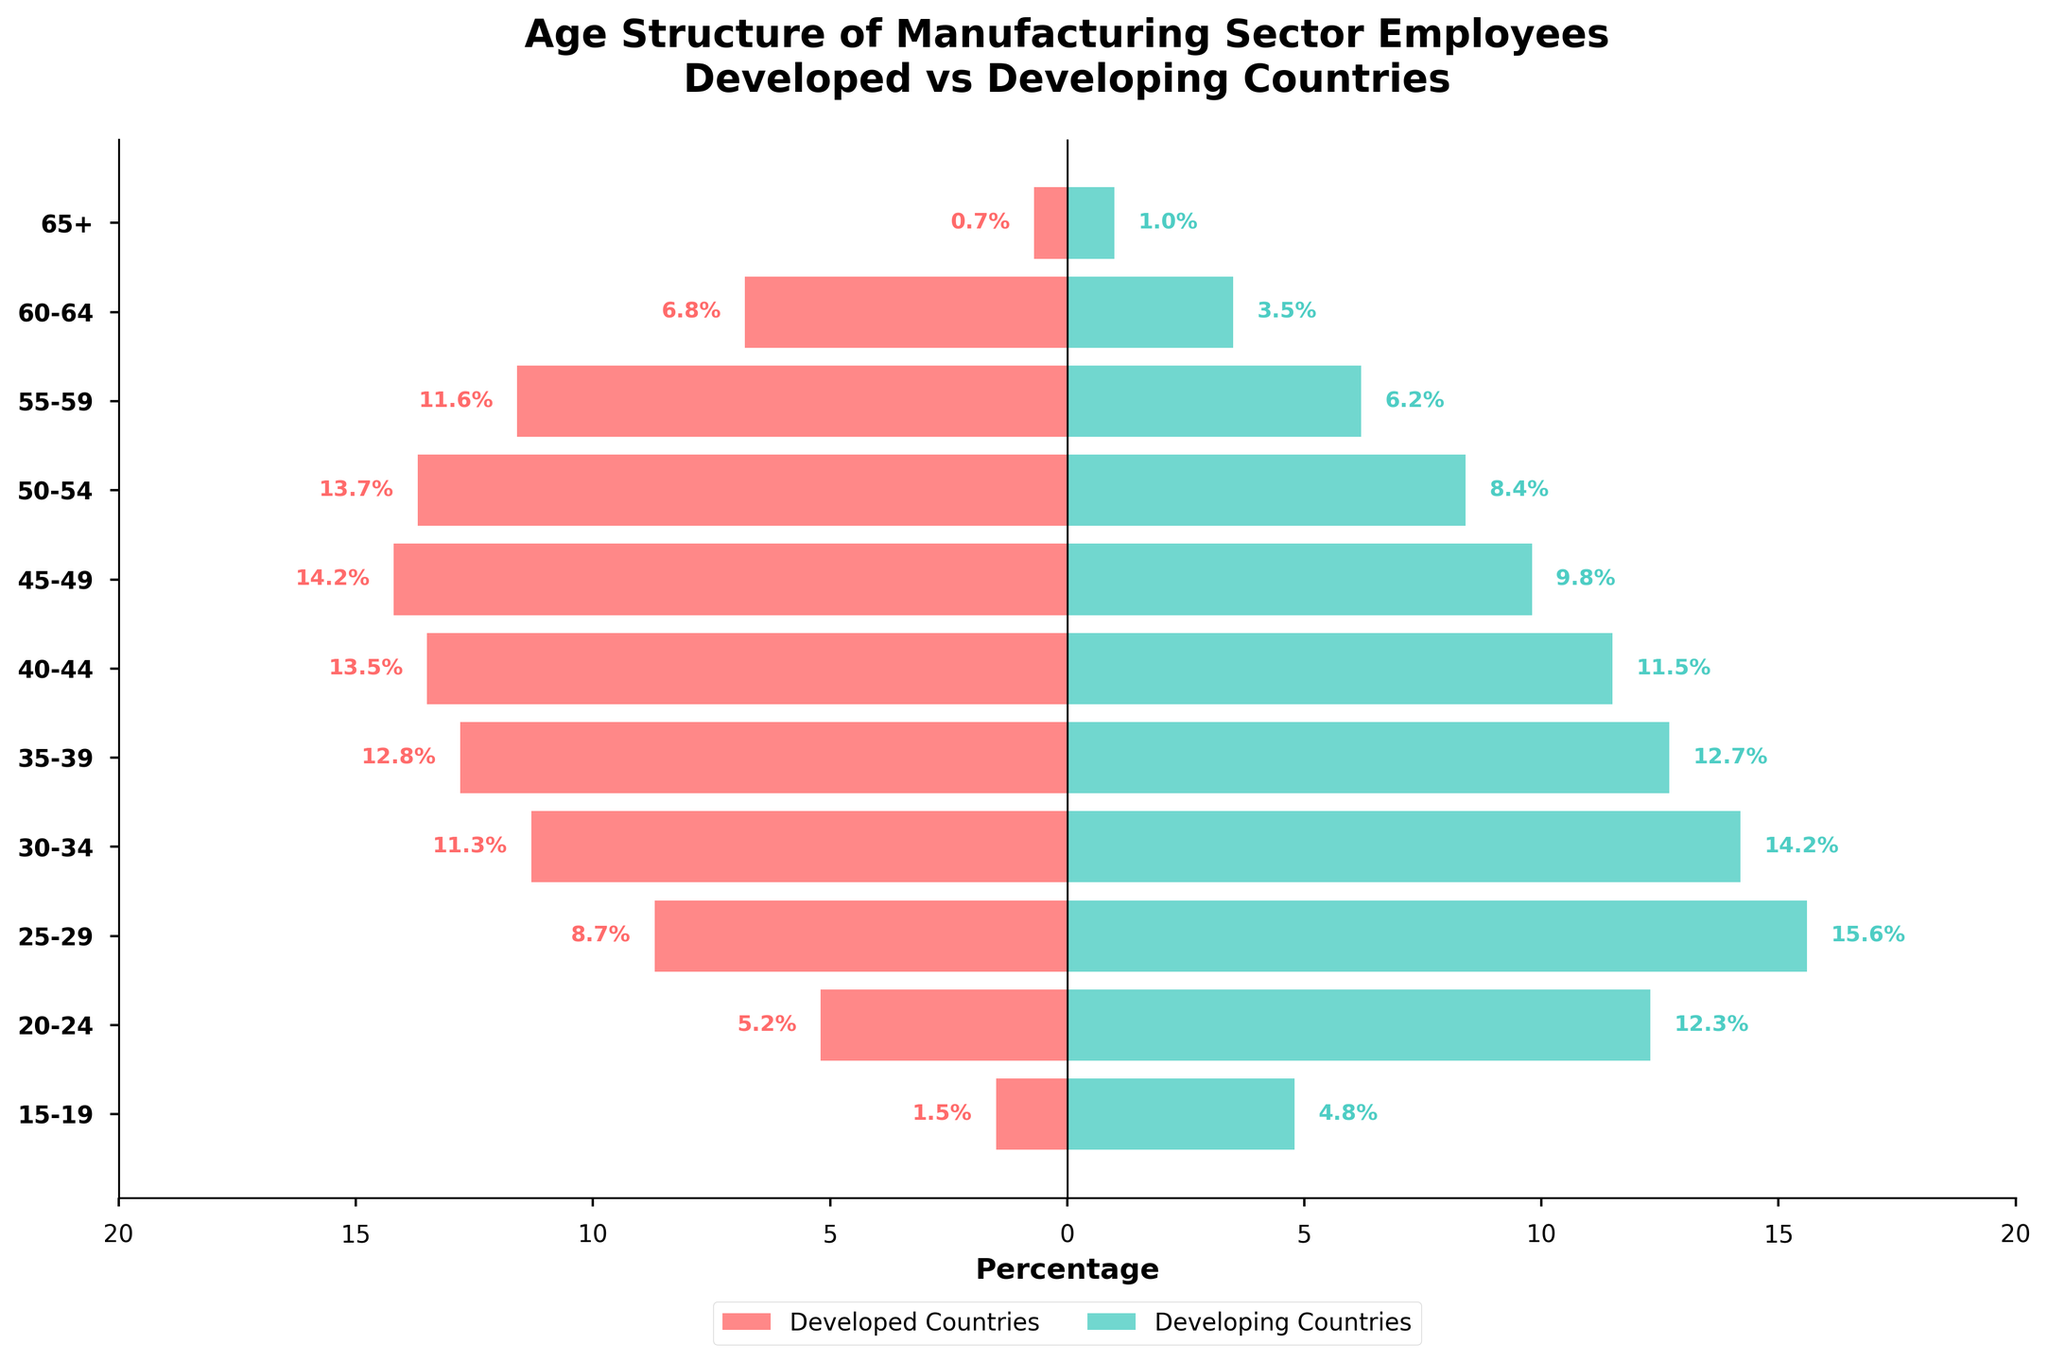What's the title of the figure? The title of the figure is located at the top and reads "Age Structure of Manufacturing Sector Employees\nDeveloped vs Developing Countries."
Answer: Age Structure of Manufacturing Sector Employees\nDeveloped vs Developing Countries What color represents the percentage of manufacturing sector employees in developed countries? The bar for developed countries is represented in red color with a percentage scale going negative to the left.
Answer: red In which age group do developing countries have the highest percentage of manufacturing sector employees? Observing the bar lengths to the right (for developing countries), the longest bar corresponds to the 25-29 age group at 15.6%.
Answer: 25-29 What percentage of employees aged 40-44 work in developed countries? Referring to the left bar for the age group 40-44, the percentage is labeled as 13.5%.
Answer: 13.5% How does the percentage of employees aged 15-19 differ between developed and developing countries? The bar lengths indicate a significant difference; the percentage is 4.8% for developing countries and 1.5% for developed countries. The difference is 3.3%.
Answer: 3.3% Which country group has a more evenly distributed age structure amongst its manufacturing sector workers? Comparing the variations in bar lengths, the developed countries have a more evenly distributed age structure, as their percentages across different age groups are more uniform.
Answer: developed countries Calculate the total percentage of manufacturing employees in developed countries aged 30-39. Adding the percentages for age groups 30-34 and 35-39, we get 11.3% + 12.8% = 24.1%.
Answer: 24.1% Is the percentage of employees aged 50-54 higher in developed or developing countries? By comparing the bars for the age group 50-54, developed countries have a higher percentage (13.7%) compared to developing countries (8.4%).
Answer: developed countries Which age group in developed countries sees the highest percentage of manufacturing workers? Referring to the figure, the age group 45-49 has the highest bar length for developed countries at 14.2%.
Answer: 45-49 What is the combined percentage of workers aged 60 and above in developing countries? Adding the percentages for age groups 60-64 and 65+, we get 3.5% + 1.0% = 4.5%.
Answer: 4.5% 